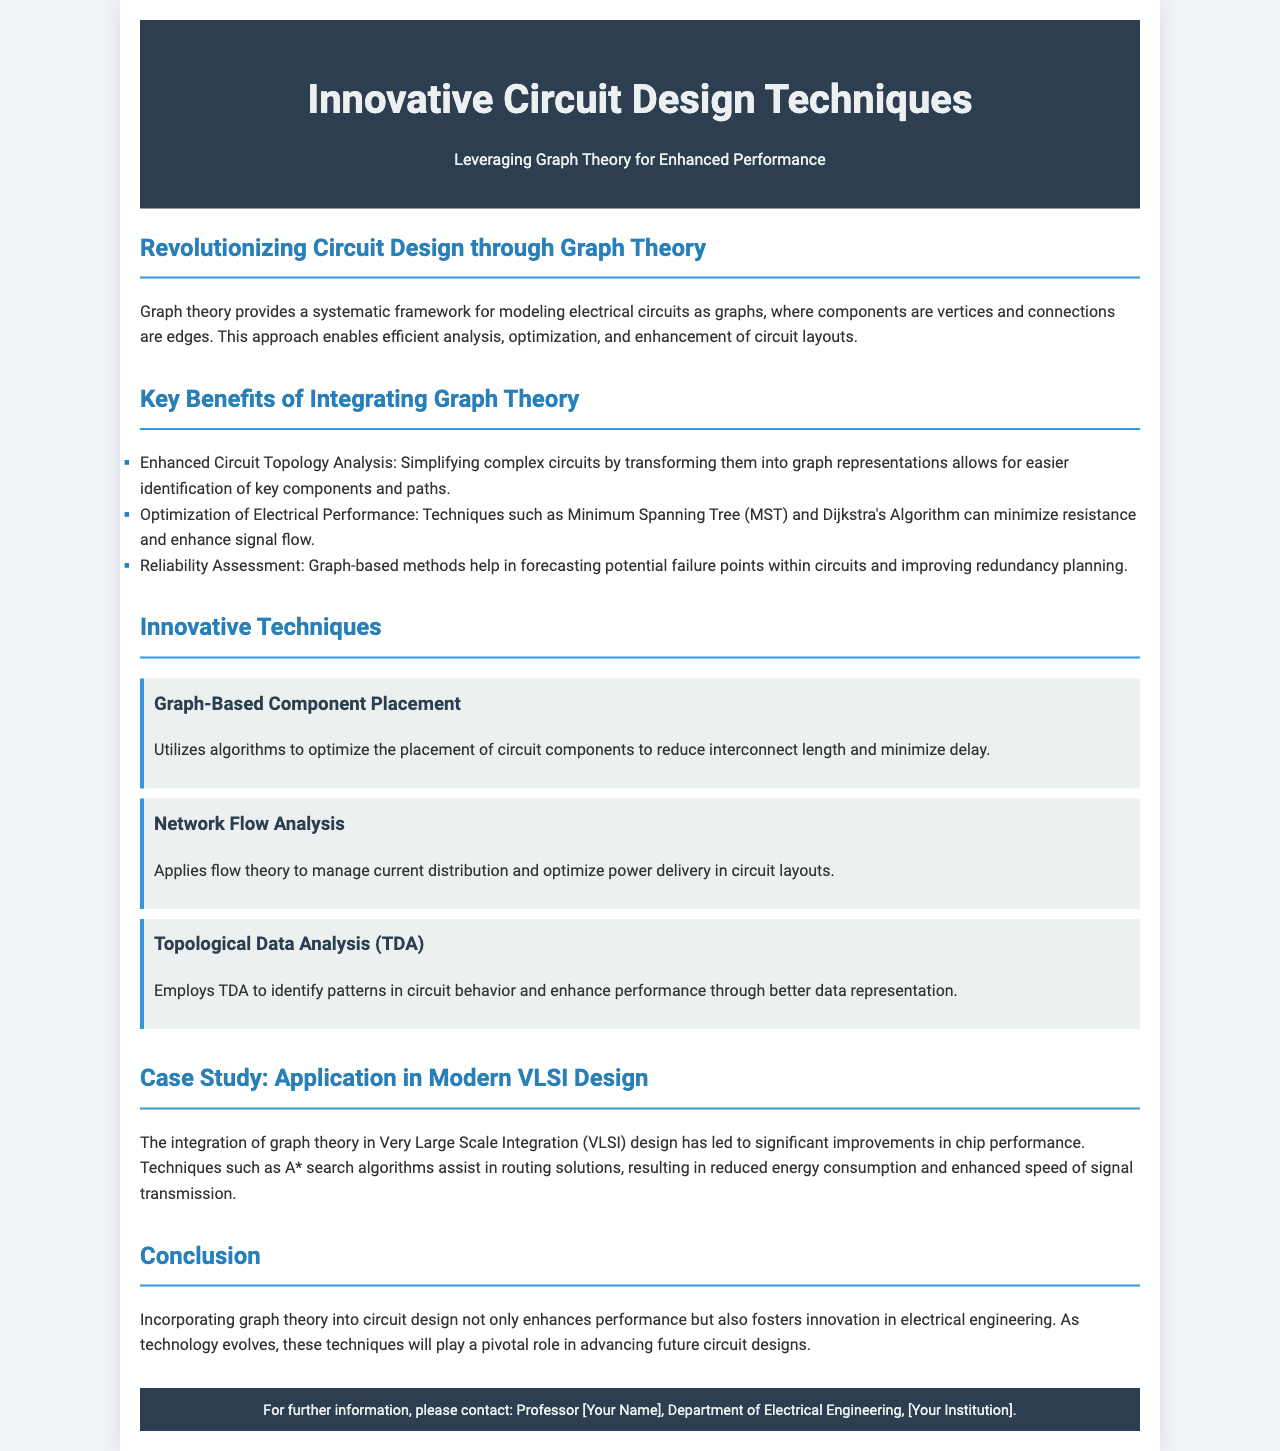What is the title of the brochure? The title of the brochure is stated in the header section and clearly defines the subject matter.
Answer: Innovative Circuit Design Techniques What are the three key benefits of integrating graph theory? The benefits are listed in a bullet format under the relevant section, summarizing the advantages of graph theory in circuit design.
Answer: Enhanced Circuit Topology Analysis, Optimization of Electrical Performance, Reliability Assessment Which innovative technique focuses on current distribution? The techniques are detailed in separate sections to illustrate their specific applications in circuit design.
Answer: Network Flow Analysis What algorithm is mentioned in the case study for routing solutions? The algorithm is specified in the context of how it contributes to improvements in VLSI design.
Answer: A* search algorithms What does TDA stand for in the context of innovative techniques? The acronym is defined in the section discussing various innovative techniques used in circuit design.
Answer: Topological Data Analysis How does graph theory affect performance in circuit design? This relationship is explained in the conclusion and summarizes the overall impact of graph theory on circuit design enhancements.
Answer: Enhances performance What is the background color of the header? The document provides specific color details for different sections, including the header.
Answer: Dark blue Who is the intended contact for further information? The contact information is provided at the footer, indicating who to reach out to for more details.
Answer: Professor [Your Name] 